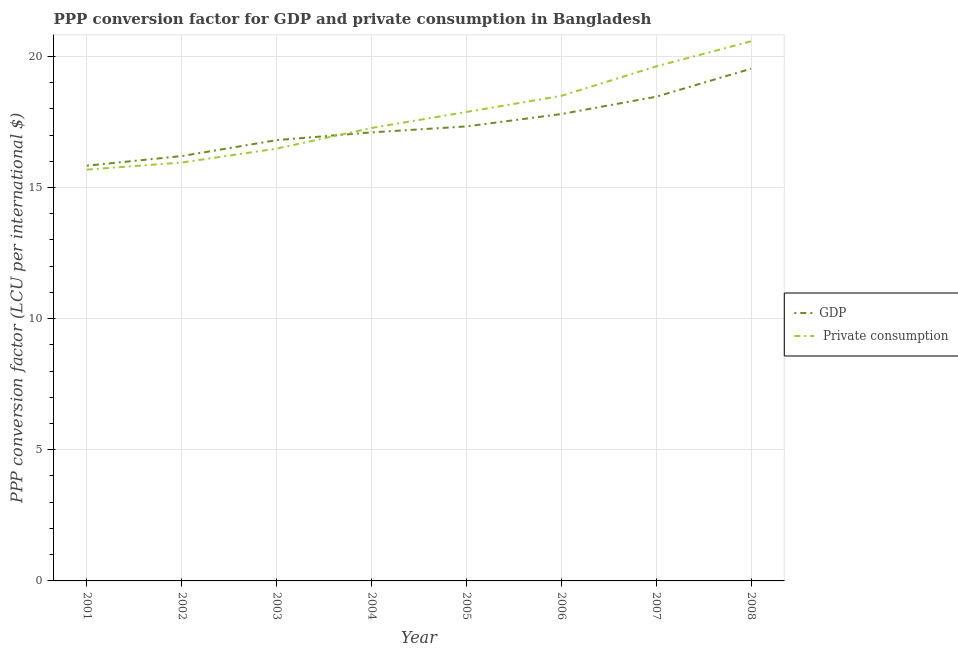How many different coloured lines are there?
Give a very brief answer. 2. What is the ppp conversion factor for private consumption in 2002?
Make the answer very short. 15.95. Across all years, what is the maximum ppp conversion factor for gdp?
Provide a succinct answer. 19.53. Across all years, what is the minimum ppp conversion factor for private consumption?
Your response must be concise. 15.68. In which year was the ppp conversion factor for private consumption maximum?
Provide a short and direct response. 2008. What is the total ppp conversion factor for private consumption in the graph?
Provide a succinct answer. 141.94. What is the difference between the ppp conversion factor for gdp in 2005 and that in 2006?
Your answer should be very brief. -0.47. What is the difference between the ppp conversion factor for gdp in 2004 and the ppp conversion factor for private consumption in 2002?
Offer a terse response. 1.15. What is the average ppp conversion factor for private consumption per year?
Your answer should be very brief. 17.74. In the year 2005, what is the difference between the ppp conversion factor for private consumption and ppp conversion factor for gdp?
Give a very brief answer. 0.55. What is the ratio of the ppp conversion factor for gdp in 2003 to that in 2005?
Your answer should be very brief. 0.97. Is the difference between the ppp conversion factor for private consumption in 2001 and 2002 greater than the difference between the ppp conversion factor for gdp in 2001 and 2002?
Offer a very short reply. Yes. What is the difference between the highest and the second highest ppp conversion factor for gdp?
Your answer should be very brief. 1.07. What is the difference between the highest and the lowest ppp conversion factor for private consumption?
Your answer should be very brief. 4.89. In how many years, is the ppp conversion factor for gdp greater than the average ppp conversion factor for gdp taken over all years?
Ensure brevity in your answer.  3. Is the ppp conversion factor for gdp strictly greater than the ppp conversion factor for private consumption over the years?
Provide a short and direct response. No. How many lines are there?
Make the answer very short. 2. How many years are there in the graph?
Make the answer very short. 8. What is the difference between two consecutive major ticks on the Y-axis?
Ensure brevity in your answer.  5. Are the values on the major ticks of Y-axis written in scientific E-notation?
Provide a short and direct response. No. Does the graph contain any zero values?
Offer a very short reply. No. Does the graph contain grids?
Provide a succinct answer. Yes. How are the legend labels stacked?
Keep it short and to the point. Vertical. What is the title of the graph?
Provide a short and direct response. PPP conversion factor for GDP and private consumption in Bangladesh. Does "Personal remittances" appear as one of the legend labels in the graph?
Provide a succinct answer. No. What is the label or title of the Y-axis?
Offer a very short reply. PPP conversion factor (LCU per international $). What is the PPP conversion factor (LCU per international $) in GDP in 2001?
Make the answer very short. 15.83. What is the PPP conversion factor (LCU per international $) of  Private consumption in 2001?
Your answer should be very brief. 15.68. What is the PPP conversion factor (LCU per international $) of GDP in 2002?
Your answer should be compact. 16.2. What is the PPP conversion factor (LCU per international $) of  Private consumption in 2002?
Provide a short and direct response. 15.95. What is the PPP conversion factor (LCU per international $) of GDP in 2003?
Make the answer very short. 16.8. What is the PPP conversion factor (LCU per international $) of  Private consumption in 2003?
Your response must be concise. 16.48. What is the PPP conversion factor (LCU per international $) of GDP in 2004?
Offer a terse response. 17.1. What is the PPP conversion factor (LCU per international $) in  Private consumption in 2004?
Ensure brevity in your answer.  17.27. What is the PPP conversion factor (LCU per international $) of GDP in 2005?
Your response must be concise. 17.33. What is the PPP conversion factor (LCU per international $) of  Private consumption in 2005?
Provide a short and direct response. 17.88. What is the PPP conversion factor (LCU per international $) of GDP in 2006?
Offer a terse response. 17.8. What is the PPP conversion factor (LCU per international $) of  Private consumption in 2006?
Provide a succinct answer. 18.49. What is the PPP conversion factor (LCU per international $) in GDP in 2007?
Your answer should be very brief. 18.46. What is the PPP conversion factor (LCU per international $) in  Private consumption in 2007?
Provide a succinct answer. 19.62. What is the PPP conversion factor (LCU per international $) of GDP in 2008?
Keep it short and to the point. 19.53. What is the PPP conversion factor (LCU per international $) in  Private consumption in 2008?
Keep it short and to the point. 20.57. Across all years, what is the maximum PPP conversion factor (LCU per international $) of GDP?
Give a very brief answer. 19.53. Across all years, what is the maximum PPP conversion factor (LCU per international $) of  Private consumption?
Give a very brief answer. 20.57. Across all years, what is the minimum PPP conversion factor (LCU per international $) in GDP?
Offer a terse response. 15.83. Across all years, what is the minimum PPP conversion factor (LCU per international $) in  Private consumption?
Offer a terse response. 15.68. What is the total PPP conversion factor (LCU per international $) in GDP in the graph?
Offer a very short reply. 139.04. What is the total PPP conversion factor (LCU per international $) of  Private consumption in the graph?
Offer a terse response. 141.94. What is the difference between the PPP conversion factor (LCU per international $) in GDP in 2001 and that in 2002?
Provide a short and direct response. -0.37. What is the difference between the PPP conversion factor (LCU per international $) of  Private consumption in 2001 and that in 2002?
Provide a short and direct response. -0.27. What is the difference between the PPP conversion factor (LCU per international $) in GDP in 2001 and that in 2003?
Ensure brevity in your answer.  -0.97. What is the difference between the PPP conversion factor (LCU per international $) of  Private consumption in 2001 and that in 2003?
Your answer should be very brief. -0.8. What is the difference between the PPP conversion factor (LCU per international $) of GDP in 2001 and that in 2004?
Provide a short and direct response. -1.27. What is the difference between the PPP conversion factor (LCU per international $) of  Private consumption in 2001 and that in 2004?
Make the answer very short. -1.59. What is the difference between the PPP conversion factor (LCU per international $) of GDP in 2001 and that in 2005?
Your answer should be compact. -1.5. What is the difference between the PPP conversion factor (LCU per international $) of  Private consumption in 2001 and that in 2005?
Offer a very short reply. -2.2. What is the difference between the PPP conversion factor (LCU per international $) in GDP in 2001 and that in 2006?
Offer a terse response. -1.97. What is the difference between the PPP conversion factor (LCU per international $) in  Private consumption in 2001 and that in 2006?
Ensure brevity in your answer.  -2.81. What is the difference between the PPP conversion factor (LCU per international $) of GDP in 2001 and that in 2007?
Your answer should be compact. -2.63. What is the difference between the PPP conversion factor (LCU per international $) of  Private consumption in 2001 and that in 2007?
Your response must be concise. -3.94. What is the difference between the PPP conversion factor (LCU per international $) of GDP in 2001 and that in 2008?
Offer a terse response. -3.7. What is the difference between the PPP conversion factor (LCU per international $) of  Private consumption in 2001 and that in 2008?
Offer a terse response. -4.89. What is the difference between the PPP conversion factor (LCU per international $) of GDP in 2002 and that in 2003?
Provide a succinct answer. -0.61. What is the difference between the PPP conversion factor (LCU per international $) in  Private consumption in 2002 and that in 2003?
Keep it short and to the point. -0.53. What is the difference between the PPP conversion factor (LCU per international $) in GDP in 2002 and that in 2004?
Your answer should be compact. -0.9. What is the difference between the PPP conversion factor (LCU per international $) in  Private consumption in 2002 and that in 2004?
Provide a short and direct response. -1.32. What is the difference between the PPP conversion factor (LCU per international $) of GDP in 2002 and that in 2005?
Make the answer very short. -1.13. What is the difference between the PPP conversion factor (LCU per international $) of  Private consumption in 2002 and that in 2005?
Give a very brief answer. -1.93. What is the difference between the PPP conversion factor (LCU per international $) of GDP in 2002 and that in 2006?
Provide a short and direct response. -1.6. What is the difference between the PPP conversion factor (LCU per international $) in  Private consumption in 2002 and that in 2006?
Give a very brief answer. -2.54. What is the difference between the PPP conversion factor (LCU per international $) of GDP in 2002 and that in 2007?
Your answer should be very brief. -2.26. What is the difference between the PPP conversion factor (LCU per international $) in  Private consumption in 2002 and that in 2007?
Your response must be concise. -3.67. What is the difference between the PPP conversion factor (LCU per international $) in GDP in 2002 and that in 2008?
Your answer should be compact. -3.33. What is the difference between the PPP conversion factor (LCU per international $) in  Private consumption in 2002 and that in 2008?
Give a very brief answer. -4.62. What is the difference between the PPP conversion factor (LCU per international $) of GDP in 2003 and that in 2004?
Provide a short and direct response. -0.3. What is the difference between the PPP conversion factor (LCU per international $) of  Private consumption in 2003 and that in 2004?
Your response must be concise. -0.79. What is the difference between the PPP conversion factor (LCU per international $) in GDP in 2003 and that in 2005?
Keep it short and to the point. -0.52. What is the difference between the PPP conversion factor (LCU per international $) in  Private consumption in 2003 and that in 2005?
Ensure brevity in your answer.  -1.4. What is the difference between the PPP conversion factor (LCU per international $) of GDP in 2003 and that in 2006?
Provide a succinct answer. -0.99. What is the difference between the PPP conversion factor (LCU per international $) of  Private consumption in 2003 and that in 2006?
Give a very brief answer. -2.01. What is the difference between the PPP conversion factor (LCU per international $) in GDP in 2003 and that in 2007?
Make the answer very short. -1.66. What is the difference between the PPP conversion factor (LCU per international $) of  Private consumption in 2003 and that in 2007?
Provide a succinct answer. -3.14. What is the difference between the PPP conversion factor (LCU per international $) of GDP in 2003 and that in 2008?
Provide a succinct answer. -2.72. What is the difference between the PPP conversion factor (LCU per international $) of  Private consumption in 2003 and that in 2008?
Keep it short and to the point. -4.09. What is the difference between the PPP conversion factor (LCU per international $) in GDP in 2004 and that in 2005?
Your answer should be very brief. -0.23. What is the difference between the PPP conversion factor (LCU per international $) of  Private consumption in 2004 and that in 2005?
Your answer should be very brief. -0.61. What is the difference between the PPP conversion factor (LCU per international $) of GDP in 2004 and that in 2006?
Give a very brief answer. -0.7. What is the difference between the PPP conversion factor (LCU per international $) in  Private consumption in 2004 and that in 2006?
Keep it short and to the point. -1.22. What is the difference between the PPP conversion factor (LCU per international $) in GDP in 2004 and that in 2007?
Your answer should be compact. -1.36. What is the difference between the PPP conversion factor (LCU per international $) of  Private consumption in 2004 and that in 2007?
Your answer should be compact. -2.35. What is the difference between the PPP conversion factor (LCU per international $) of GDP in 2004 and that in 2008?
Your response must be concise. -2.43. What is the difference between the PPP conversion factor (LCU per international $) in  Private consumption in 2004 and that in 2008?
Keep it short and to the point. -3.3. What is the difference between the PPP conversion factor (LCU per international $) of GDP in 2005 and that in 2006?
Offer a very short reply. -0.47. What is the difference between the PPP conversion factor (LCU per international $) in  Private consumption in 2005 and that in 2006?
Ensure brevity in your answer.  -0.61. What is the difference between the PPP conversion factor (LCU per international $) in GDP in 2005 and that in 2007?
Ensure brevity in your answer.  -1.13. What is the difference between the PPP conversion factor (LCU per international $) in  Private consumption in 2005 and that in 2007?
Your response must be concise. -1.74. What is the difference between the PPP conversion factor (LCU per international $) of GDP in 2005 and that in 2008?
Provide a short and direct response. -2.2. What is the difference between the PPP conversion factor (LCU per international $) in  Private consumption in 2005 and that in 2008?
Keep it short and to the point. -2.69. What is the difference between the PPP conversion factor (LCU per international $) of GDP in 2006 and that in 2007?
Your response must be concise. -0.66. What is the difference between the PPP conversion factor (LCU per international $) of  Private consumption in 2006 and that in 2007?
Your answer should be very brief. -1.12. What is the difference between the PPP conversion factor (LCU per international $) of GDP in 2006 and that in 2008?
Make the answer very short. -1.73. What is the difference between the PPP conversion factor (LCU per international $) in  Private consumption in 2006 and that in 2008?
Your answer should be very brief. -2.08. What is the difference between the PPP conversion factor (LCU per international $) in GDP in 2007 and that in 2008?
Provide a short and direct response. -1.07. What is the difference between the PPP conversion factor (LCU per international $) in  Private consumption in 2007 and that in 2008?
Give a very brief answer. -0.96. What is the difference between the PPP conversion factor (LCU per international $) of GDP in 2001 and the PPP conversion factor (LCU per international $) of  Private consumption in 2002?
Your answer should be very brief. -0.12. What is the difference between the PPP conversion factor (LCU per international $) of GDP in 2001 and the PPP conversion factor (LCU per international $) of  Private consumption in 2003?
Keep it short and to the point. -0.65. What is the difference between the PPP conversion factor (LCU per international $) in GDP in 2001 and the PPP conversion factor (LCU per international $) in  Private consumption in 2004?
Provide a short and direct response. -1.44. What is the difference between the PPP conversion factor (LCU per international $) in GDP in 2001 and the PPP conversion factor (LCU per international $) in  Private consumption in 2005?
Provide a succinct answer. -2.05. What is the difference between the PPP conversion factor (LCU per international $) in GDP in 2001 and the PPP conversion factor (LCU per international $) in  Private consumption in 2006?
Give a very brief answer. -2.66. What is the difference between the PPP conversion factor (LCU per international $) in GDP in 2001 and the PPP conversion factor (LCU per international $) in  Private consumption in 2007?
Make the answer very short. -3.79. What is the difference between the PPP conversion factor (LCU per international $) of GDP in 2001 and the PPP conversion factor (LCU per international $) of  Private consumption in 2008?
Make the answer very short. -4.74. What is the difference between the PPP conversion factor (LCU per international $) in GDP in 2002 and the PPP conversion factor (LCU per international $) in  Private consumption in 2003?
Ensure brevity in your answer.  -0.28. What is the difference between the PPP conversion factor (LCU per international $) of GDP in 2002 and the PPP conversion factor (LCU per international $) of  Private consumption in 2004?
Keep it short and to the point. -1.07. What is the difference between the PPP conversion factor (LCU per international $) of GDP in 2002 and the PPP conversion factor (LCU per international $) of  Private consumption in 2005?
Make the answer very short. -1.68. What is the difference between the PPP conversion factor (LCU per international $) in GDP in 2002 and the PPP conversion factor (LCU per international $) in  Private consumption in 2006?
Your answer should be very brief. -2.29. What is the difference between the PPP conversion factor (LCU per international $) of GDP in 2002 and the PPP conversion factor (LCU per international $) of  Private consumption in 2007?
Your answer should be very brief. -3.42. What is the difference between the PPP conversion factor (LCU per international $) in GDP in 2002 and the PPP conversion factor (LCU per international $) in  Private consumption in 2008?
Make the answer very short. -4.38. What is the difference between the PPP conversion factor (LCU per international $) in GDP in 2003 and the PPP conversion factor (LCU per international $) in  Private consumption in 2004?
Ensure brevity in your answer.  -0.46. What is the difference between the PPP conversion factor (LCU per international $) in GDP in 2003 and the PPP conversion factor (LCU per international $) in  Private consumption in 2005?
Your answer should be very brief. -1.07. What is the difference between the PPP conversion factor (LCU per international $) of GDP in 2003 and the PPP conversion factor (LCU per international $) of  Private consumption in 2006?
Your answer should be compact. -1.69. What is the difference between the PPP conversion factor (LCU per international $) of GDP in 2003 and the PPP conversion factor (LCU per international $) of  Private consumption in 2007?
Give a very brief answer. -2.81. What is the difference between the PPP conversion factor (LCU per international $) in GDP in 2003 and the PPP conversion factor (LCU per international $) in  Private consumption in 2008?
Your answer should be compact. -3.77. What is the difference between the PPP conversion factor (LCU per international $) of GDP in 2004 and the PPP conversion factor (LCU per international $) of  Private consumption in 2005?
Offer a very short reply. -0.78. What is the difference between the PPP conversion factor (LCU per international $) of GDP in 2004 and the PPP conversion factor (LCU per international $) of  Private consumption in 2006?
Ensure brevity in your answer.  -1.39. What is the difference between the PPP conversion factor (LCU per international $) of GDP in 2004 and the PPP conversion factor (LCU per international $) of  Private consumption in 2007?
Your response must be concise. -2.52. What is the difference between the PPP conversion factor (LCU per international $) of GDP in 2004 and the PPP conversion factor (LCU per international $) of  Private consumption in 2008?
Provide a succinct answer. -3.47. What is the difference between the PPP conversion factor (LCU per international $) of GDP in 2005 and the PPP conversion factor (LCU per international $) of  Private consumption in 2006?
Keep it short and to the point. -1.16. What is the difference between the PPP conversion factor (LCU per international $) in GDP in 2005 and the PPP conversion factor (LCU per international $) in  Private consumption in 2007?
Your answer should be compact. -2.29. What is the difference between the PPP conversion factor (LCU per international $) in GDP in 2005 and the PPP conversion factor (LCU per international $) in  Private consumption in 2008?
Offer a very short reply. -3.25. What is the difference between the PPP conversion factor (LCU per international $) of GDP in 2006 and the PPP conversion factor (LCU per international $) of  Private consumption in 2007?
Your answer should be very brief. -1.82. What is the difference between the PPP conversion factor (LCU per international $) of GDP in 2006 and the PPP conversion factor (LCU per international $) of  Private consumption in 2008?
Your answer should be very brief. -2.77. What is the difference between the PPP conversion factor (LCU per international $) of GDP in 2007 and the PPP conversion factor (LCU per international $) of  Private consumption in 2008?
Provide a short and direct response. -2.11. What is the average PPP conversion factor (LCU per international $) in GDP per year?
Your answer should be very brief. 17.38. What is the average PPP conversion factor (LCU per international $) in  Private consumption per year?
Your answer should be very brief. 17.74. In the year 2001, what is the difference between the PPP conversion factor (LCU per international $) in GDP and PPP conversion factor (LCU per international $) in  Private consumption?
Provide a succinct answer. 0.15. In the year 2002, what is the difference between the PPP conversion factor (LCU per international $) of GDP and PPP conversion factor (LCU per international $) of  Private consumption?
Your answer should be compact. 0.25. In the year 2003, what is the difference between the PPP conversion factor (LCU per international $) of GDP and PPP conversion factor (LCU per international $) of  Private consumption?
Your answer should be compact. 0.32. In the year 2004, what is the difference between the PPP conversion factor (LCU per international $) in GDP and PPP conversion factor (LCU per international $) in  Private consumption?
Give a very brief answer. -0.17. In the year 2005, what is the difference between the PPP conversion factor (LCU per international $) of GDP and PPP conversion factor (LCU per international $) of  Private consumption?
Give a very brief answer. -0.55. In the year 2006, what is the difference between the PPP conversion factor (LCU per international $) in GDP and PPP conversion factor (LCU per international $) in  Private consumption?
Make the answer very short. -0.69. In the year 2007, what is the difference between the PPP conversion factor (LCU per international $) in GDP and PPP conversion factor (LCU per international $) in  Private consumption?
Give a very brief answer. -1.16. In the year 2008, what is the difference between the PPP conversion factor (LCU per international $) in GDP and PPP conversion factor (LCU per international $) in  Private consumption?
Offer a very short reply. -1.05. What is the ratio of the PPP conversion factor (LCU per international $) of GDP in 2001 to that in 2002?
Offer a terse response. 0.98. What is the ratio of the PPP conversion factor (LCU per international $) of  Private consumption in 2001 to that in 2002?
Your answer should be compact. 0.98. What is the ratio of the PPP conversion factor (LCU per international $) of GDP in 2001 to that in 2003?
Offer a very short reply. 0.94. What is the ratio of the PPP conversion factor (LCU per international $) of  Private consumption in 2001 to that in 2003?
Make the answer very short. 0.95. What is the ratio of the PPP conversion factor (LCU per international $) of GDP in 2001 to that in 2004?
Keep it short and to the point. 0.93. What is the ratio of the PPP conversion factor (LCU per international $) in  Private consumption in 2001 to that in 2004?
Your response must be concise. 0.91. What is the ratio of the PPP conversion factor (LCU per international $) of GDP in 2001 to that in 2005?
Provide a short and direct response. 0.91. What is the ratio of the PPP conversion factor (LCU per international $) of  Private consumption in 2001 to that in 2005?
Provide a short and direct response. 0.88. What is the ratio of the PPP conversion factor (LCU per international $) of GDP in 2001 to that in 2006?
Give a very brief answer. 0.89. What is the ratio of the PPP conversion factor (LCU per international $) in  Private consumption in 2001 to that in 2006?
Offer a very short reply. 0.85. What is the ratio of the PPP conversion factor (LCU per international $) of GDP in 2001 to that in 2007?
Offer a terse response. 0.86. What is the ratio of the PPP conversion factor (LCU per international $) in  Private consumption in 2001 to that in 2007?
Provide a short and direct response. 0.8. What is the ratio of the PPP conversion factor (LCU per international $) in GDP in 2001 to that in 2008?
Ensure brevity in your answer.  0.81. What is the ratio of the PPP conversion factor (LCU per international $) of  Private consumption in 2001 to that in 2008?
Make the answer very short. 0.76. What is the ratio of the PPP conversion factor (LCU per international $) in GDP in 2002 to that in 2003?
Provide a succinct answer. 0.96. What is the ratio of the PPP conversion factor (LCU per international $) of  Private consumption in 2002 to that in 2003?
Provide a short and direct response. 0.97. What is the ratio of the PPP conversion factor (LCU per international $) of GDP in 2002 to that in 2004?
Offer a very short reply. 0.95. What is the ratio of the PPP conversion factor (LCU per international $) in  Private consumption in 2002 to that in 2004?
Keep it short and to the point. 0.92. What is the ratio of the PPP conversion factor (LCU per international $) of GDP in 2002 to that in 2005?
Provide a succinct answer. 0.93. What is the ratio of the PPP conversion factor (LCU per international $) in  Private consumption in 2002 to that in 2005?
Make the answer very short. 0.89. What is the ratio of the PPP conversion factor (LCU per international $) in GDP in 2002 to that in 2006?
Provide a succinct answer. 0.91. What is the ratio of the PPP conversion factor (LCU per international $) in  Private consumption in 2002 to that in 2006?
Your response must be concise. 0.86. What is the ratio of the PPP conversion factor (LCU per international $) in GDP in 2002 to that in 2007?
Provide a succinct answer. 0.88. What is the ratio of the PPP conversion factor (LCU per international $) in  Private consumption in 2002 to that in 2007?
Provide a succinct answer. 0.81. What is the ratio of the PPP conversion factor (LCU per international $) of GDP in 2002 to that in 2008?
Ensure brevity in your answer.  0.83. What is the ratio of the PPP conversion factor (LCU per international $) of  Private consumption in 2002 to that in 2008?
Ensure brevity in your answer.  0.78. What is the ratio of the PPP conversion factor (LCU per international $) in GDP in 2003 to that in 2004?
Provide a short and direct response. 0.98. What is the ratio of the PPP conversion factor (LCU per international $) of  Private consumption in 2003 to that in 2004?
Provide a succinct answer. 0.95. What is the ratio of the PPP conversion factor (LCU per international $) of GDP in 2003 to that in 2005?
Give a very brief answer. 0.97. What is the ratio of the PPP conversion factor (LCU per international $) of  Private consumption in 2003 to that in 2005?
Provide a short and direct response. 0.92. What is the ratio of the PPP conversion factor (LCU per international $) in GDP in 2003 to that in 2006?
Offer a terse response. 0.94. What is the ratio of the PPP conversion factor (LCU per international $) in  Private consumption in 2003 to that in 2006?
Your answer should be compact. 0.89. What is the ratio of the PPP conversion factor (LCU per international $) of GDP in 2003 to that in 2007?
Offer a very short reply. 0.91. What is the ratio of the PPP conversion factor (LCU per international $) of  Private consumption in 2003 to that in 2007?
Provide a succinct answer. 0.84. What is the ratio of the PPP conversion factor (LCU per international $) of GDP in 2003 to that in 2008?
Your response must be concise. 0.86. What is the ratio of the PPP conversion factor (LCU per international $) in  Private consumption in 2003 to that in 2008?
Offer a terse response. 0.8. What is the ratio of the PPP conversion factor (LCU per international $) of GDP in 2004 to that in 2005?
Offer a very short reply. 0.99. What is the ratio of the PPP conversion factor (LCU per international $) in  Private consumption in 2004 to that in 2005?
Ensure brevity in your answer.  0.97. What is the ratio of the PPP conversion factor (LCU per international $) of GDP in 2004 to that in 2006?
Make the answer very short. 0.96. What is the ratio of the PPP conversion factor (LCU per international $) in  Private consumption in 2004 to that in 2006?
Provide a short and direct response. 0.93. What is the ratio of the PPP conversion factor (LCU per international $) in GDP in 2004 to that in 2007?
Offer a terse response. 0.93. What is the ratio of the PPP conversion factor (LCU per international $) in  Private consumption in 2004 to that in 2007?
Provide a succinct answer. 0.88. What is the ratio of the PPP conversion factor (LCU per international $) of GDP in 2004 to that in 2008?
Provide a succinct answer. 0.88. What is the ratio of the PPP conversion factor (LCU per international $) of  Private consumption in 2004 to that in 2008?
Keep it short and to the point. 0.84. What is the ratio of the PPP conversion factor (LCU per international $) of GDP in 2005 to that in 2006?
Offer a terse response. 0.97. What is the ratio of the PPP conversion factor (LCU per international $) in  Private consumption in 2005 to that in 2006?
Your response must be concise. 0.97. What is the ratio of the PPP conversion factor (LCU per international $) in GDP in 2005 to that in 2007?
Give a very brief answer. 0.94. What is the ratio of the PPP conversion factor (LCU per international $) of  Private consumption in 2005 to that in 2007?
Keep it short and to the point. 0.91. What is the ratio of the PPP conversion factor (LCU per international $) of GDP in 2005 to that in 2008?
Keep it short and to the point. 0.89. What is the ratio of the PPP conversion factor (LCU per international $) of  Private consumption in 2005 to that in 2008?
Offer a very short reply. 0.87. What is the ratio of the PPP conversion factor (LCU per international $) of GDP in 2006 to that in 2007?
Offer a terse response. 0.96. What is the ratio of the PPP conversion factor (LCU per international $) of  Private consumption in 2006 to that in 2007?
Provide a succinct answer. 0.94. What is the ratio of the PPP conversion factor (LCU per international $) in GDP in 2006 to that in 2008?
Ensure brevity in your answer.  0.91. What is the ratio of the PPP conversion factor (LCU per international $) in  Private consumption in 2006 to that in 2008?
Keep it short and to the point. 0.9. What is the ratio of the PPP conversion factor (LCU per international $) in GDP in 2007 to that in 2008?
Your answer should be very brief. 0.95. What is the ratio of the PPP conversion factor (LCU per international $) of  Private consumption in 2007 to that in 2008?
Give a very brief answer. 0.95. What is the difference between the highest and the second highest PPP conversion factor (LCU per international $) in GDP?
Provide a short and direct response. 1.07. What is the difference between the highest and the second highest PPP conversion factor (LCU per international $) of  Private consumption?
Ensure brevity in your answer.  0.96. What is the difference between the highest and the lowest PPP conversion factor (LCU per international $) in GDP?
Ensure brevity in your answer.  3.7. What is the difference between the highest and the lowest PPP conversion factor (LCU per international $) in  Private consumption?
Provide a short and direct response. 4.89. 